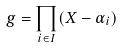Convert formula to latex. <formula><loc_0><loc_0><loc_500><loc_500>g = \prod _ { i \in I } ( X - \alpha _ { i } )</formula> 